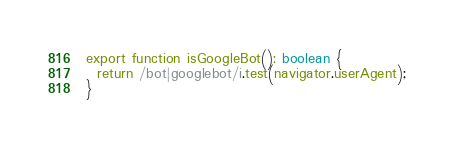<code> <loc_0><loc_0><loc_500><loc_500><_TypeScript_>export function isGoogleBot(): boolean {
  return /bot|googlebot/i.test(navigator.userAgent);
}
</code> 